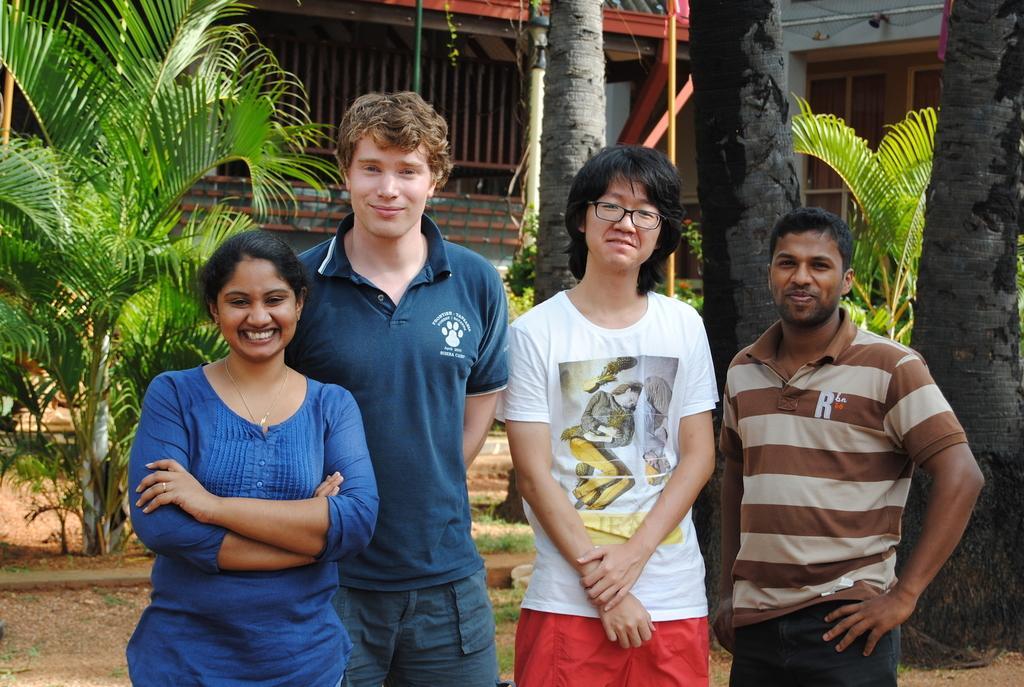Please provide a concise description of this image. In the image there are few people standing and smiling. Behind them there are trees. In the background there are buildings with walls, windows and rods. 